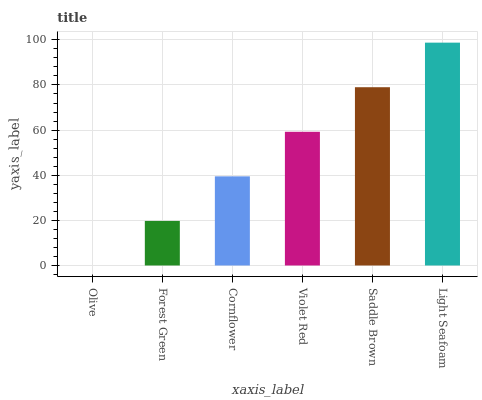Is Olive the minimum?
Answer yes or no. Yes. Is Light Seafoam the maximum?
Answer yes or no. Yes. Is Forest Green the minimum?
Answer yes or no. No. Is Forest Green the maximum?
Answer yes or no. No. Is Forest Green greater than Olive?
Answer yes or no. Yes. Is Olive less than Forest Green?
Answer yes or no. Yes. Is Olive greater than Forest Green?
Answer yes or no. No. Is Forest Green less than Olive?
Answer yes or no. No. Is Violet Red the high median?
Answer yes or no. Yes. Is Cornflower the low median?
Answer yes or no. Yes. Is Forest Green the high median?
Answer yes or no. No. Is Violet Red the low median?
Answer yes or no. No. 